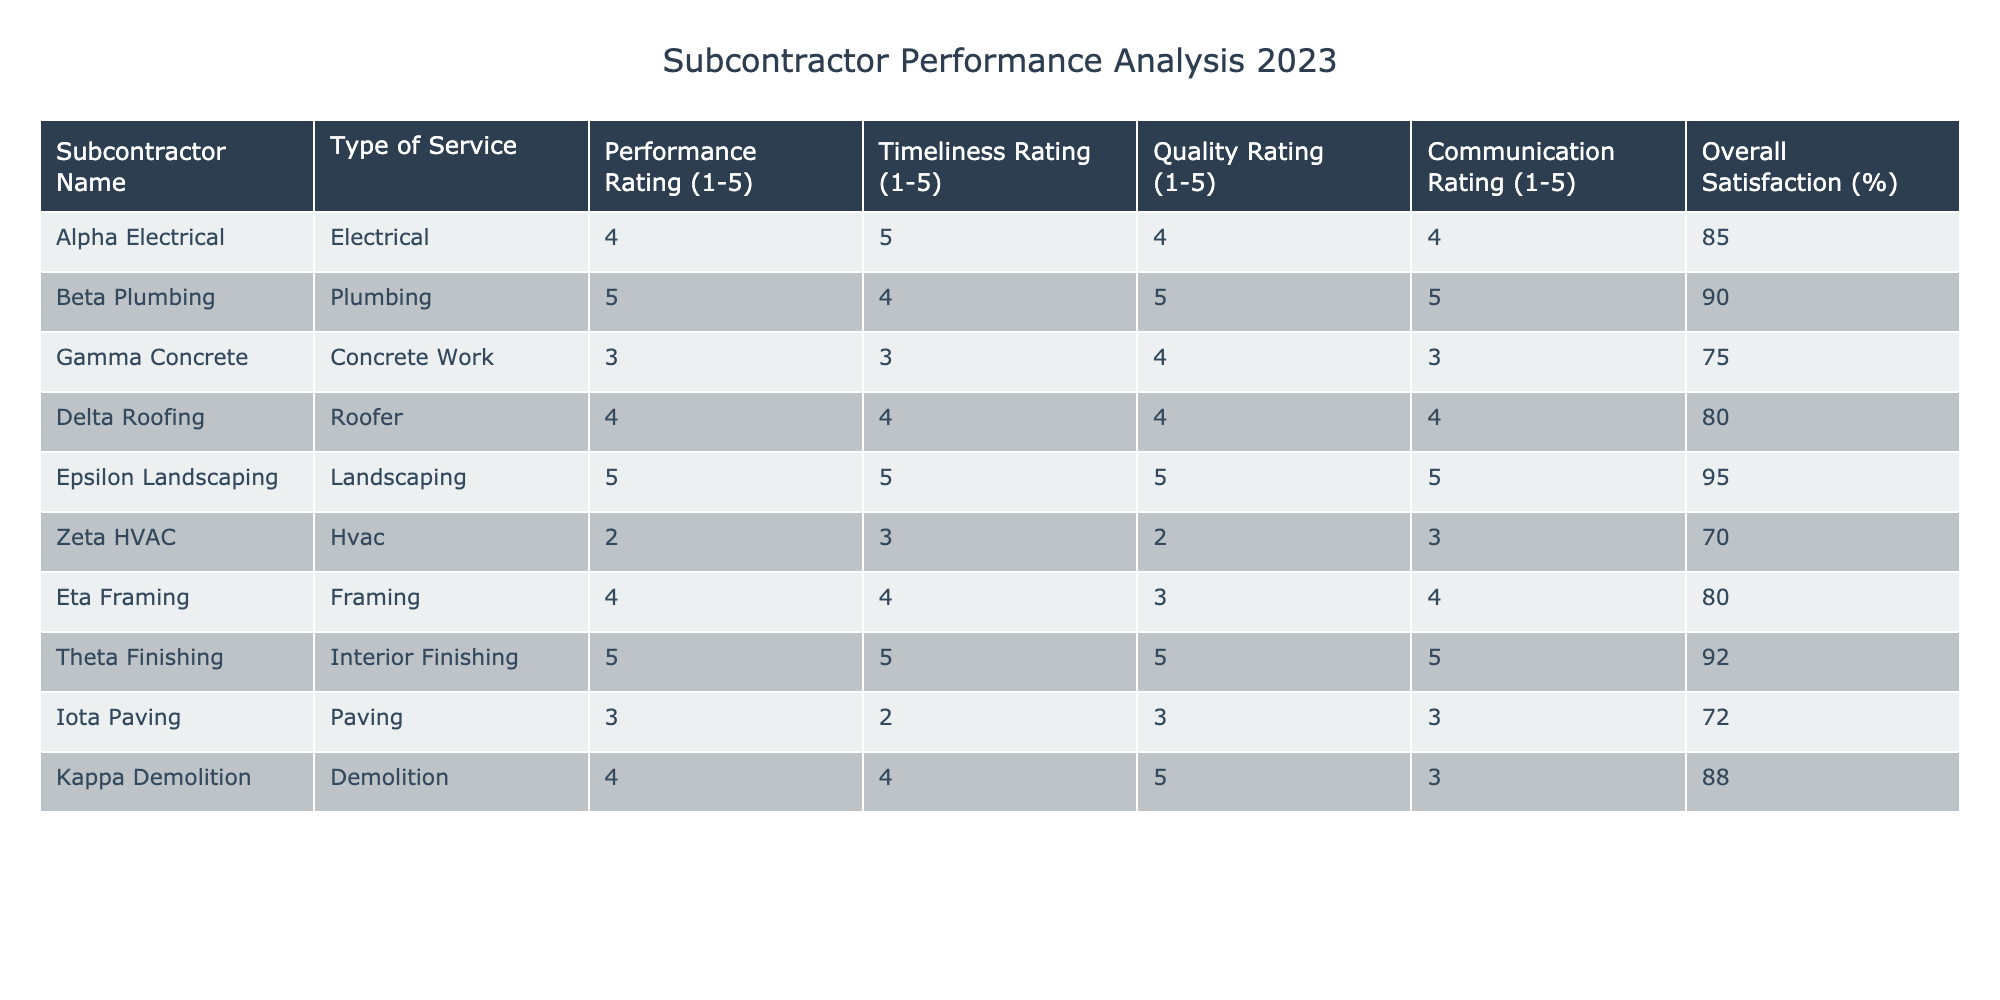What is the performance rating of Beta Plumbing? The performance rating for Beta Plumbing is directly listed in the table. It states that Beta Plumbing has a performance rating of 5.
Answer: 5 Which subcontractor achieved the highest overall satisfaction percentage? By examining the 'Overall Satisfaction (%)' column, Epsilon Landscaping has the highest score at 95%.
Answer: 95 Is the average timeliness rating of all subcontractors greater than 4? To find the average, first add all the timeliness ratings: 5 + 4 + 3 + 4 + 5 + 3 + 4 + 5 + 2 + 4 = 43. There are 10 subcontractors, so dividing gives 43/10 = 4.3, which is more than 4.
Answer: Yes What is the difference in performance ratings between Zeta HVAC and Theta Finishing? Zeta HVAC has a performance rating of 2, while Theta Finishing has a performance rating of 5. The difference is calculated by subtracting Zeta's rating from Theta's: 5 - 2 = 3.
Answer: 3 How many subcontractors have an overall satisfaction rating of 80% or higher? By counting the rows, I find that Alpha Electrical, Beta Plumbing, Epsilon Landscaping, Delta Roofing, Kappa Demolition, and Theta Finishing have overall satisfaction ratings of 80% or higher. This gives us a total of 6 subcontractors.
Answer: 6 What is the average quality rating for all subcontractors? The quality ratings from the table are 4, 5, 4, 4, 5, 2, 3, 5, 3, and 5. Adding these gives a total of 46. Dividing by the number of subcontractors (10) results in an average quality rating of 4.6.
Answer: 4.6 Did any subcontractor receive a communication rating of 2? The table lists the communication ratings, and Zeta HVAC has a rating of 2, indicating that there is indeed a subcontractor that fits this criteria.
Answer: Yes Which type of service has the highest average performance rating? First, I group the performance ratings by type of service. The averages are calculated as follows: Electrical (4), Plumbing (5), Concrete Work (3), Roofer (4), Landscaping (5), HVAC (2), Framing (4), Interior Finishing (5), Paving (3), and Demolition (4). The highest average is for Plumbing and Landscaping at 5.
Answer: Plumbing and Landscaping 